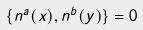<formula> <loc_0><loc_0><loc_500><loc_500>\{ n ^ { a } ( x ) , n ^ { b } ( y ) \} = 0</formula> 